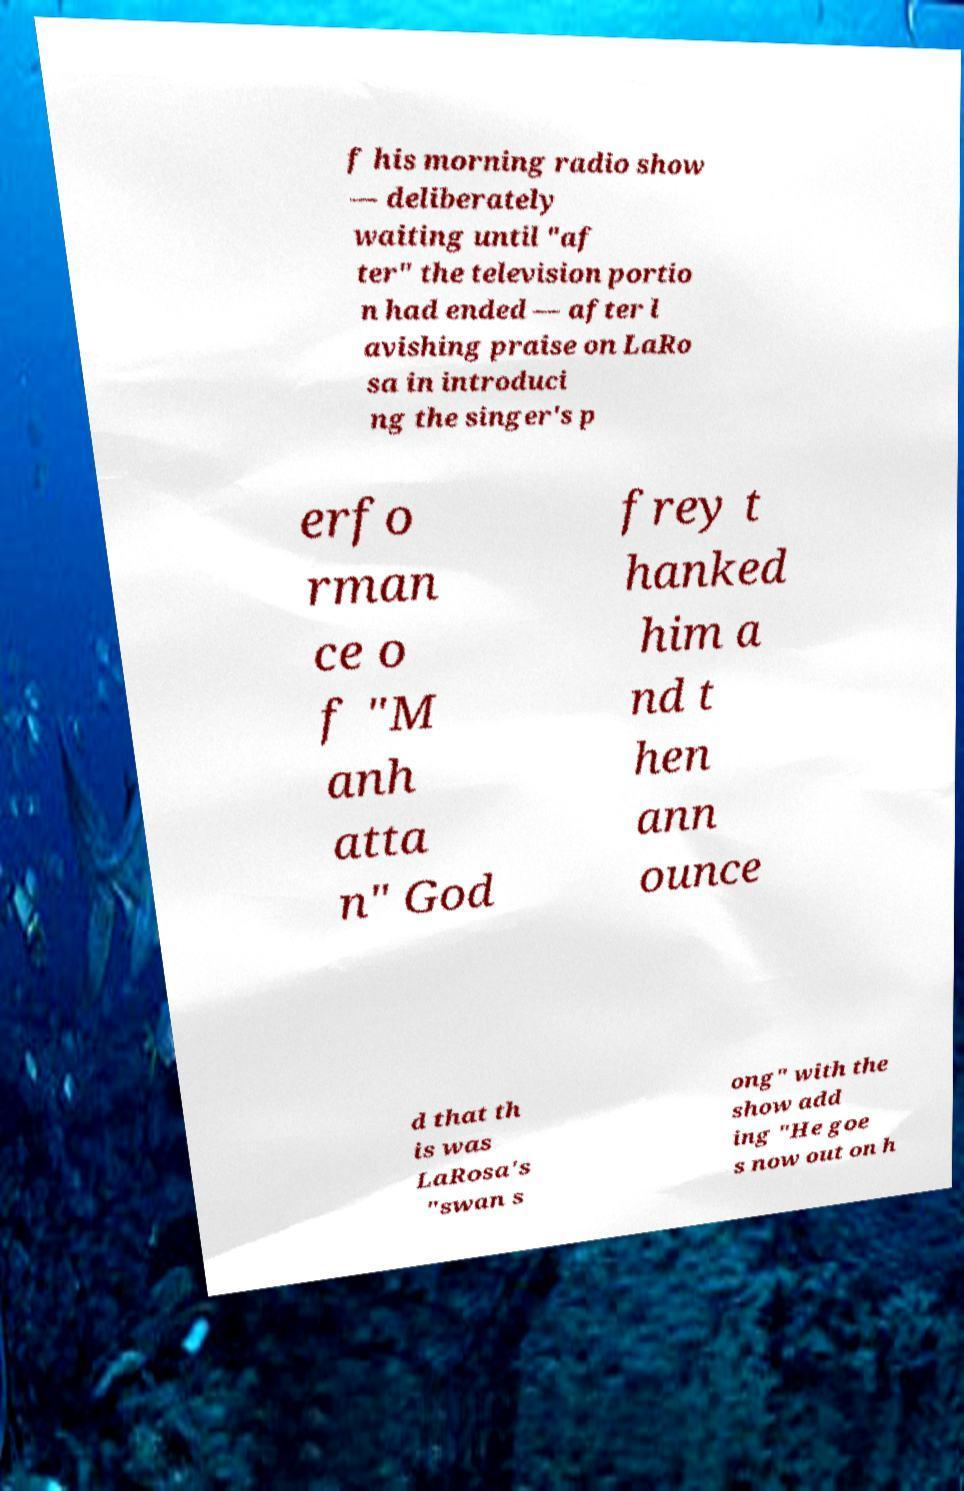There's text embedded in this image that I need extracted. Can you transcribe it verbatim? f his morning radio show — deliberately waiting until "af ter" the television portio n had ended — after l avishing praise on LaRo sa in introduci ng the singer's p erfo rman ce o f "M anh atta n" God frey t hanked him a nd t hen ann ounce d that th is was LaRosa's "swan s ong" with the show add ing "He goe s now out on h 